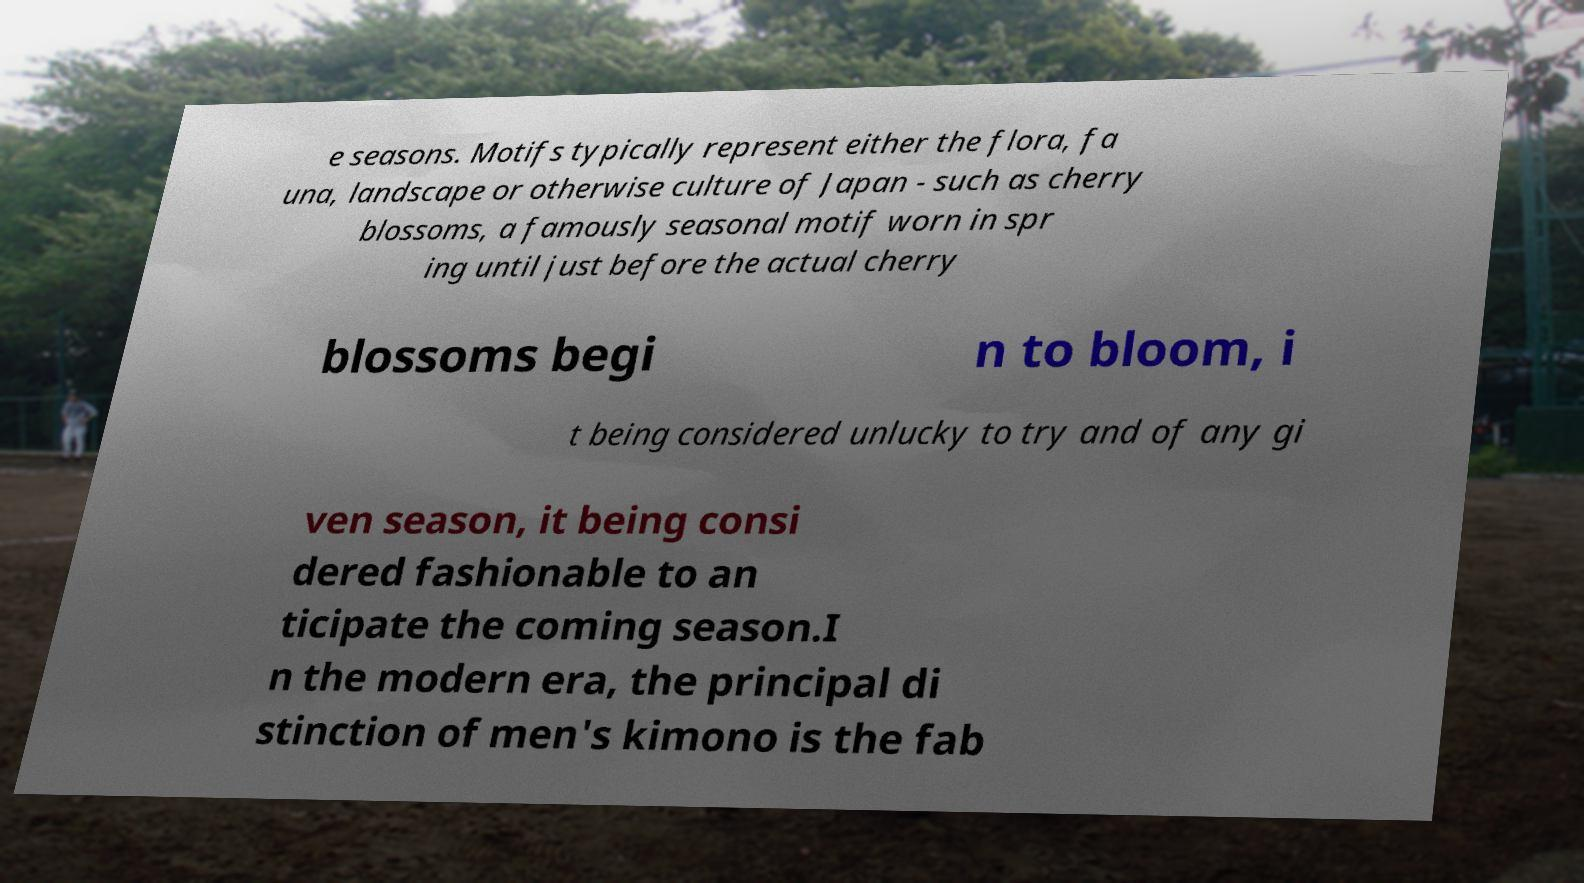For documentation purposes, I need the text within this image transcribed. Could you provide that? e seasons. Motifs typically represent either the flora, fa una, landscape or otherwise culture of Japan - such as cherry blossoms, a famously seasonal motif worn in spr ing until just before the actual cherry blossoms begi n to bloom, i t being considered unlucky to try and of any gi ven season, it being consi dered fashionable to an ticipate the coming season.I n the modern era, the principal di stinction of men's kimono is the fab 